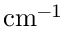Convert formula to latex. <formula><loc_0><loc_0><loc_500><loc_500>c m ^ { - 1 }</formula> 